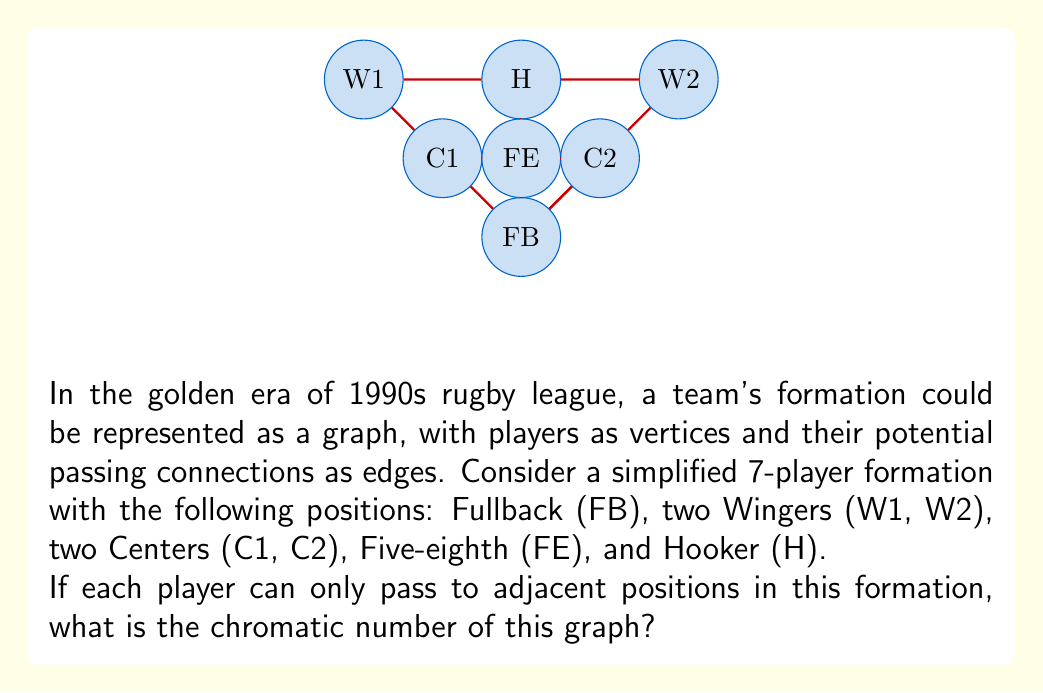Can you answer this question? To solve this problem, let's approach it step-by-step using graph theory concepts:

1) First, we need to understand what the chromatic number represents. The chromatic number of a graph is the minimum number of colors needed to color the vertices so that no two adjacent vertices share the same color.

2) Let's identify the adjacencies in our graph:
   - FB is adjacent to C1, C2, and FE
   - W1 is adjacent to C1 and H
   - W2 is adjacent to C2 and H
   - C1 is adjacent to FB, W1, FE, and H
   - C2 is adjacent to FB, W2, FE, and H
   - FE is adjacent to FB, C1, C2, and H
   - H is adjacent to W1, W2, C1, C2, and FE

3) To find the chromatic number, we'll try to color the graph with the minimum number of colors:

   - Start with FB. We can color it with color 1.
   - C1 and C2 are adjacent to FB, so they need different colors. Color C1 with color 2 and C2 with color 3.
   - FE is adjacent to FB, C1, and C2, so it needs a new color. Color FE with color 4.
   - H is adjacent to C1, C2, and FE, so it needs a new color. Color H with color 5.
   - W1 is only adjacent to C1 and H, so we can use color 3 (same as C2).
   - W2 is only adjacent to C2 and H, so we can use color 2 (same as C1).

4) We've successfully colored the graph using 5 colors, and it's impossible to do it with fewer colors due to the connections between FB, C1, C2, FE, and H forming a complete subgraph (K5).

Therefore, the chromatic number of this graph is 5.
Answer: 5 